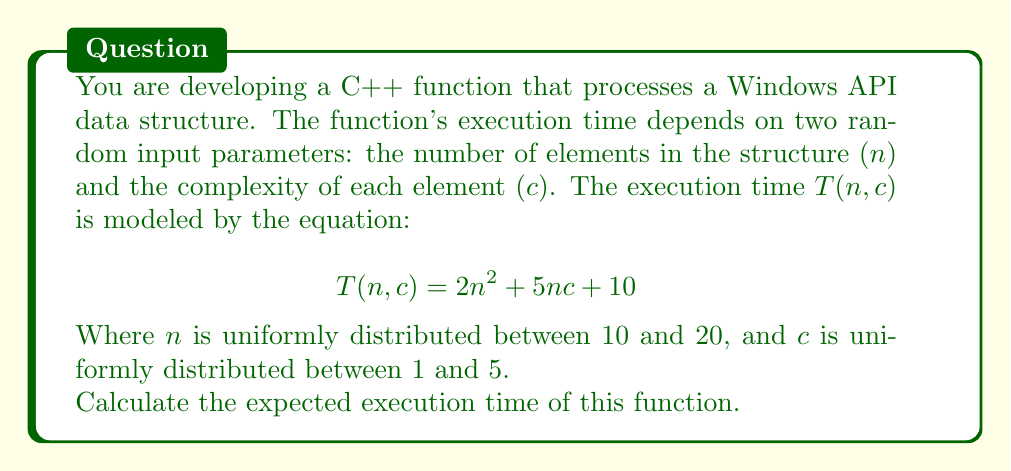Show me your answer to this math problem. To find the expected execution time, we need to calculate $E[T(n,c)]$. Let's break this down step-by-step:

1) First, we need to find $E[n]$ and $E[c]$:
   
   $E[n] = \frac{10 + 20}{2} = 15$
   $E[c] = \frac{1 + 5}{2} = 3$

2) Now, let's consider the terms in $T(n,c)$:
   
   $E[2n^2] = 2E[n^2]$
   $E[5nc] = 5E[n]E[c]$ (because $n$ and $c$ are independent)
   $E[10] = 10$

3) We need to calculate $E[n^2]$. For a uniform distribution:
   
   $E[n^2] = \frac{a^2 + ab + b^2}{3}$, where $a$ and $b$ are the lower and upper bounds.
   
   $E[n^2] = \frac{10^2 + 10(20) + 20^2}{3} = \frac{100 + 200 + 400}{3} = \frac{700}{3} \approx 233.33$

4) Now we can put it all together:
   
   $E[T(n,c)] = 2E[n^2] + 5E[n]E[c] + 10$
   
   $= 2(233.33) + 5(15)(3) + 10$
   
   $= 466.66 + 225 + 10$
   
   $= 701.66$

Therefore, the expected execution time is approximately 701.66 time units.
Answer: 701.66 time units 